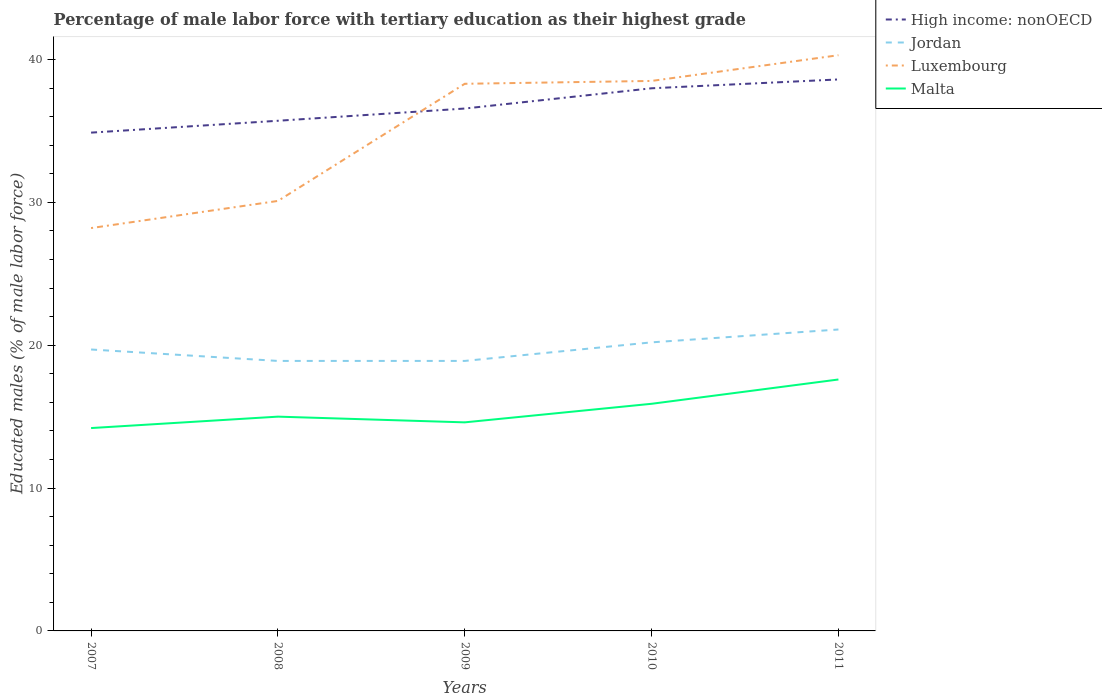How many different coloured lines are there?
Offer a very short reply. 4. Is the number of lines equal to the number of legend labels?
Provide a succinct answer. Yes. Across all years, what is the maximum percentage of male labor force with tertiary education in High income: nonOECD?
Keep it short and to the point. 34.88. In which year was the percentage of male labor force with tertiary education in Jordan maximum?
Provide a succinct answer. 2008. What is the total percentage of male labor force with tertiary education in Luxembourg in the graph?
Your answer should be compact. -1.9. What is the difference between the highest and the second highest percentage of male labor force with tertiary education in Luxembourg?
Provide a short and direct response. 12.1. Is the percentage of male labor force with tertiary education in Luxembourg strictly greater than the percentage of male labor force with tertiary education in Jordan over the years?
Your response must be concise. No. How many lines are there?
Your answer should be very brief. 4. What is the difference between two consecutive major ticks on the Y-axis?
Make the answer very short. 10. Does the graph contain any zero values?
Ensure brevity in your answer.  No. Does the graph contain grids?
Your answer should be very brief. No. Where does the legend appear in the graph?
Offer a terse response. Top right. What is the title of the graph?
Offer a very short reply. Percentage of male labor force with tertiary education as their highest grade. What is the label or title of the Y-axis?
Provide a short and direct response. Educated males (% of male labor force). What is the Educated males (% of male labor force) in High income: nonOECD in 2007?
Offer a terse response. 34.88. What is the Educated males (% of male labor force) in Jordan in 2007?
Your answer should be very brief. 19.7. What is the Educated males (% of male labor force) in Luxembourg in 2007?
Offer a very short reply. 28.2. What is the Educated males (% of male labor force) of Malta in 2007?
Ensure brevity in your answer.  14.2. What is the Educated males (% of male labor force) in High income: nonOECD in 2008?
Give a very brief answer. 35.71. What is the Educated males (% of male labor force) in Jordan in 2008?
Provide a succinct answer. 18.9. What is the Educated males (% of male labor force) of Luxembourg in 2008?
Provide a short and direct response. 30.1. What is the Educated males (% of male labor force) of Malta in 2008?
Keep it short and to the point. 15. What is the Educated males (% of male labor force) of High income: nonOECD in 2009?
Make the answer very short. 36.57. What is the Educated males (% of male labor force) in Jordan in 2009?
Keep it short and to the point. 18.9. What is the Educated males (% of male labor force) in Luxembourg in 2009?
Provide a short and direct response. 38.3. What is the Educated males (% of male labor force) in Malta in 2009?
Your answer should be compact. 14.6. What is the Educated males (% of male labor force) of High income: nonOECD in 2010?
Provide a short and direct response. 37.99. What is the Educated males (% of male labor force) in Jordan in 2010?
Make the answer very short. 20.2. What is the Educated males (% of male labor force) of Luxembourg in 2010?
Provide a short and direct response. 38.5. What is the Educated males (% of male labor force) in Malta in 2010?
Ensure brevity in your answer.  15.9. What is the Educated males (% of male labor force) in High income: nonOECD in 2011?
Offer a very short reply. 38.6. What is the Educated males (% of male labor force) in Jordan in 2011?
Ensure brevity in your answer.  21.1. What is the Educated males (% of male labor force) in Luxembourg in 2011?
Your answer should be compact. 40.3. What is the Educated males (% of male labor force) in Malta in 2011?
Offer a terse response. 17.6. Across all years, what is the maximum Educated males (% of male labor force) in High income: nonOECD?
Ensure brevity in your answer.  38.6. Across all years, what is the maximum Educated males (% of male labor force) of Jordan?
Offer a very short reply. 21.1. Across all years, what is the maximum Educated males (% of male labor force) in Luxembourg?
Offer a terse response. 40.3. Across all years, what is the maximum Educated males (% of male labor force) in Malta?
Your answer should be very brief. 17.6. Across all years, what is the minimum Educated males (% of male labor force) of High income: nonOECD?
Ensure brevity in your answer.  34.88. Across all years, what is the minimum Educated males (% of male labor force) of Jordan?
Give a very brief answer. 18.9. Across all years, what is the minimum Educated males (% of male labor force) of Luxembourg?
Your answer should be very brief. 28.2. Across all years, what is the minimum Educated males (% of male labor force) in Malta?
Offer a very short reply. 14.2. What is the total Educated males (% of male labor force) in High income: nonOECD in the graph?
Ensure brevity in your answer.  183.75. What is the total Educated males (% of male labor force) of Jordan in the graph?
Your response must be concise. 98.8. What is the total Educated males (% of male labor force) in Luxembourg in the graph?
Ensure brevity in your answer.  175.4. What is the total Educated males (% of male labor force) of Malta in the graph?
Offer a very short reply. 77.3. What is the difference between the Educated males (% of male labor force) in High income: nonOECD in 2007 and that in 2008?
Make the answer very short. -0.83. What is the difference between the Educated males (% of male labor force) of Malta in 2007 and that in 2008?
Offer a very short reply. -0.8. What is the difference between the Educated males (% of male labor force) in High income: nonOECD in 2007 and that in 2009?
Keep it short and to the point. -1.69. What is the difference between the Educated males (% of male labor force) in Luxembourg in 2007 and that in 2009?
Ensure brevity in your answer.  -10.1. What is the difference between the Educated males (% of male labor force) in Malta in 2007 and that in 2009?
Keep it short and to the point. -0.4. What is the difference between the Educated males (% of male labor force) of High income: nonOECD in 2007 and that in 2010?
Ensure brevity in your answer.  -3.1. What is the difference between the Educated males (% of male labor force) of Jordan in 2007 and that in 2010?
Keep it short and to the point. -0.5. What is the difference between the Educated males (% of male labor force) of Luxembourg in 2007 and that in 2010?
Your response must be concise. -10.3. What is the difference between the Educated males (% of male labor force) of Malta in 2007 and that in 2010?
Provide a succinct answer. -1.7. What is the difference between the Educated males (% of male labor force) in High income: nonOECD in 2007 and that in 2011?
Provide a succinct answer. -3.72. What is the difference between the Educated males (% of male labor force) in High income: nonOECD in 2008 and that in 2009?
Your answer should be compact. -0.86. What is the difference between the Educated males (% of male labor force) in Jordan in 2008 and that in 2009?
Give a very brief answer. 0. What is the difference between the Educated males (% of male labor force) of Luxembourg in 2008 and that in 2009?
Give a very brief answer. -8.2. What is the difference between the Educated males (% of male labor force) of High income: nonOECD in 2008 and that in 2010?
Give a very brief answer. -2.27. What is the difference between the Educated males (% of male labor force) of Luxembourg in 2008 and that in 2010?
Offer a very short reply. -8.4. What is the difference between the Educated males (% of male labor force) of High income: nonOECD in 2008 and that in 2011?
Make the answer very short. -2.89. What is the difference between the Educated males (% of male labor force) of Luxembourg in 2008 and that in 2011?
Your answer should be compact. -10.2. What is the difference between the Educated males (% of male labor force) in High income: nonOECD in 2009 and that in 2010?
Offer a terse response. -1.42. What is the difference between the Educated males (% of male labor force) of Luxembourg in 2009 and that in 2010?
Ensure brevity in your answer.  -0.2. What is the difference between the Educated males (% of male labor force) of Malta in 2009 and that in 2010?
Offer a very short reply. -1.3. What is the difference between the Educated males (% of male labor force) of High income: nonOECD in 2009 and that in 2011?
Offer a very short reply. -2.04. What is the difference between the Educated males (% of male labor force) of Luxembourg in 2009 and that in 2011?
Provide a succinct answer. -2. What is the difference between the Educated males (% of male labor force) of Malta in 2009 and that in 2011?
Keep it short and to the point. -3. What is the difference between the Educated males (% of male labor force) of High income: nonOECD in 2010 and that in 2011?
Make the answer very short. -0.62. What is the difference between the Educated males (% of male labor force) in Jordan in 2010 and that in 2011?
Your answer should be compact. -0.9. What is the difference between the Educated males (% of male labor force) of Luxembourg in 2010 and that in 2011?
Ensure brevity in your answer.  -1.8. What is the difference between the Educated males (% of male labor force) of High income: nonOECD in 2007 and the Educated males (% of male labor force) of Jordan in 2008?
Offer a very short reply. 15.98. What is the difference between the Educated males (% of male labor force) of High income: nonOECD in 2007 and the Educated males (% of male labor force) of Luxembourg in 2008?
Provide a succinct answer. 4.78. What is the difference between the Educated males (% of male labor force) of High income: nonOECD in 2007 and the Educated males (% of male labor force) of Malta in 2008?
Provide a short and direct response. 19.88. What is the difference between the Educated males (% of male labor force) in Jordan in 2007 and the Educated males (% of male labor force) in Luxembourg in 2008?
Provide a succinct answer. -10.4. What is the difference between the Educated males (% of male labor force) of High income: nonOECD in 2007 and the Educated males (% of male labor force) of Jordan in 2009?
Your answer should be very brief. 15.98. What is the difference between the Educated males (% of male labor force) in High income: nonOECD in 2007 and the Educated males (% of male labor force) in Luxembourg in 2009?
Give a very brief answer. -3.42. What is the difference between the Educated males (% of male labor force) of High income: nonOECD in 2007 and the Educated males (% of male labor force) of Malta in 2009?
Ensure brevity in your answer.  20.28. What is the difference between the Educated males (% of male labor force) of Jordan in 2007 and the Educated males (% of male labor force) of Luxembourg in 2009?
Offer a very short reply. -18.6. What is the difference between the Educated males (% of male labor force) in Luxembourg in 2007 and the Educated males (% of male labor force) in Malta in 2009?
Your response must be concise. 13.6. What is the difference between the Educated males (% of male labor force) in High income: nonOECD in 2007 and the Educated males (% of male labor force) in Jordan in 2010?
Offer a very short reply. 14.68. What is the difference between the Educated males (% of male labor force) in High income: nonOECD in 2007 and the Educated males (% of male labor force) in Luxembourg in 2010?
Give a very brief answer. -3.62. What is the difference between the Educated males (% of male labor force) of High income: nonOECD in 2007 and the Educated males (% of male labor force) of Malta in 2010?
Offer a very short reply. 18.98. What is the difference between the Educated males (% of male labor force) of Jordan in 2007 and the Educated males (% of male labor force) of Luxembourg in 2010?
Keep it short and to the point. -18.8. What is the difference between the Educated males (% of male labor force) in Jordan in 2007 and the Educated males (% of male labor force) in Malta in 2010?
Make the answer very short. 3.8. What is the difference between the Educated males (% of male labor force) in Luxembourg in 2007 and the Educated males (% of male labor force) in Malta in 2010?
Keep it short and to the point. 12.3. What is the difference between the Educated males (% of male labor force) in High income: nonOECD in 2007 and the Educated males (% of male labor force) in Jordan in 2011?
Your response must be concise. 13.78. What is the difference between the Educated males (% of male labor force) of High income: nonOECD in 2007 and the Educated males (% of male labor force) of Luxembourg in 2011?
Offer a very short reply. -5.42. What is the difference between the Educated males (% of male labor force) in High income: nonOECD in 2007 and the Educated males (% of male labor force) in Malta in 2011?
Your answer should be very brief. 17.28. What is the difference between the Educated males (% of male labor force) of Jordan in 2007 and the Educated males (% of male labor force) of Luxembourg in 2011?
Your answer should be compact. -20.6. What is the difference between the Educated males (% of male labor force) in Jordan in 2007 and the Educated males (% of male labor force) in Malta in 2011?
Keep it short and to the point. 2.1. What is the difference between the Educated males (% of male labor force) in High income: nonOECD in 2008 and the Educated males (% of male labor force) in Jordan in 2009?
Ensure brevity in your answer.  16.81. What is the difference between the Educated males (% of male labor force) of High income: nonOECD in 2008 and the Educated males (% of male labor force) of Luxembourg in 2009?
Offer a very short reply. -2.59. What is the difference between the Educated males (% of male labor force) in High income: nonOECD in 2008 and the Educated males (% of male labor force) in Malta in 2009?
Make the answer very short. 21.11. What is the difference between the Educated males (% of male labor force) of Jordan in 2008 and the Educated males (% of male labor force) of Luxembourg in 2009?
Your answer should be very brief. -19.4. What is the difference between the Educated males (% of male labor force) of Luxembourg in 2008 and the Educated males (% of male labor force) of Malta in 2009?
Keep it short and to the point. 15.5. What is the difference between the Educated males (% of male labor force) in High income: nonOECD in 2008 and the Educated males (% of male labor force) in Jordan in 2010?
Your response must be concise. 15.51. What is the difference between the Educated males (% of male labor force) of High income: nonOECD in 2008 and the Educated males (% of male labor force) of Luxembourg in 2010?
Your answer should be very brief. -2.79. What is the difference between the Educated males (% of male labor force) in High income: nonOECD in 2008 and the Educated males (% of male labor force) in Malta in 2010?
Provide a succinct answer. 19.81. What is the difference between the Educated males (% of male labor force) of Jordan in 2008 and the Educated males (% of male labor force) of Luxembourg in 2010?
Your answer should be compact. -19.6. What is the difference between the Educated males (% of male labor force) of Jordan in 2008 and the Educated males (% of male labor force) of Malta in 2010?
Ensure brevity in your answer.  3. What is the difference between the Educated males (% of male labor force) of High income: nonOECD in 2008 and the Educated males (% of male labor force) of Jordan in 2011?
Make the answer very short. 14.61. What is the difference between the Educated males (% of male labor force) in High income: nonOECD in 2008 and the Educated males (% of male labor force) in Luxembourg in 2011?
Ensure brevity in your answer.  -4.59. What is the difference between the Educated males (% of male labor force) in High income: nonOECD in 2008 and the Educated males (% of male labor force) in Malta in 2011?
Keep it short and to the point. 18.11. What is the difference between the Educated males (% of male labor force) in Jordan in 2008 and the Educated males (% of male labor force) in Luxembourg in 2011?
Provide a short and direct response. -21.4. What is the difference between the Educated males (% of male labor force) of Jordan in 2008 and the Educated males (% of male labor force) of Malta in 2011?
Keep it short and to the point. 1.3. What is the difference between the Educated males (% of male labor force) of Luxembourg in 2008 and the Educated males (% of male labor force) of Malta in 2011?
Provide a short and direct response. 12.5. What is the difference between the Educated males (% of male labor force) in High income: nonOECD in 2009 and the Educated males (% of male labor force) in Jordan in 2010?
Provide a succinct answer. 16.37. What is the difference between the Educated males (% of male labor force) of High income: nonOECD in 2009 and the Educated males (% of male labor force) of Luxembourg in 2010?
Give a very brief answer. -1.93. What is the difference between the Educated males (% of male labor force) in High income: nonOECD in 2009 and the Educated males (% of male labor force) in Malta in 2010?
Provide a short and direct response. 20.67. What is the difference between the Educated males (% of male labor force) in Jordan in 2009 and the Educated males (% of male labor force) in Luxembourg in 2010?
Your answer should be very brief. -19.6. What is the difference between the Educated males (% of male labor force) of Jordan in 2009 and the Educated males (% of male labor force) of Malta in 2010?
Your answer should be very brief. 3. What is the difference between the Educated males (% of male labor force) of Luxembourg in 2009 and the Educated males (% of male labor force) of Malta in 2010?
Offer a very short reply. 22.4. What is the difference between the Educated males (% of male labor force) of High income: nonOECD in 2009 and the Educated males (% of male labor force) of Jordan in 2011?
Your answer should be compact. 15.47. What is the difference between the Educated males (% of male labor force) in High income: nonOECD in 2009 and the Educated males (% of male labor force) in Luxembourg in 2011?
Give a very brief answer. -3.73. What is the difference between the Educated males (% of male labor force) in High income: nonOECD in 2009 and the Educated males (% of male labor force) in Malta in 2011?
Your response must be concise. 18.97. What is the difference between the Educated males (% of male labor force) of Jordan in 2009 and the Educated males (% of male labor force) of Luxembourg in 2011?
Your answer should be very brief. -21.4. What is the difference between the Educated males (% of male labor force) in Luxembourg in 2009 and the Educated males (% of male labor force) in Malta in 2011?
Keep it short and to the point. 20.7. What is the difference between the Educated males (% of male labor force) of High income: nonOECD in 2010 and the Educated males (% of male labor force) of Jordan in 2011?
Give a very brief answer. 16.89. What is the difference between the Educated males (% of male labor force) in High income: nonOECD in 2010 and the Educated males (% of male labor force) in Luxembourg in 2011?
Make the answer very short. -2.31. What is the difference between the Educated males (% of male labor force) in High income: nonOECD in 2010 and the Educated males (% of male labor force) in Malta in 2011?
Offer a very short reply. 20.39. What is the difference between the Educated males (% of male labor force) of Jordan in 2010 and the Educated males (% of male labor force) of Luxembourg in 2011?
Offer a very short reply. -20.1. What is the difference between the Educated males (% of male labor force) in Jordan in 2010 and the Educated males (% of male labor force) in Malta in 2011?
Offer a very short reply. 2.6. What is the difference between the Educated males (% of male labor force) in Luxembourg in 2010 and the Educated males (% of male labor force) in Malta in 2011?
Provide a succinct answer. 20.9. What is the average Educated males (% of male labor force) of High income: nonOECD per year?
Make the answer very short. 36.75. What is the average Educated males (% of male labor force) of Jordan per year?
Keep it short and to the point. 19.76. What is the average Educated males (% of male labor force) in Luxembourg per year?
Provide a succinct answer. 35.08. What is the average Educated males (% of male labor force) of Malta per year?
Keep it short and to the point. 15.46. In the year 2007, what is the difference between the Educated males (% of male labor force) in High income: nonOECD and Educated males (% of male labor force) in Jordan?
Ensure brevity in your answer.  15.18. In the year 2007, what is the difference between the Educated males (% of male labor force) of High income: nonOECD and Educated males (% of male labor force) of Luxembourg?
Your answer should be very brief. 6.68. In the year 2007, what is the difference between the Educated males (% of male labor force) in High income: nonOECD and Educated males (% of male labor force) in Malta?
Your answer should be very brief. 20.68. In the year 2007, what is the difference between the Educated males (% of male labor force) of Jordan and Educated males (% of male labor force) of Luxembourg?
Offer a very short reply. -8.5. In the year 2007, what is the difference between the Educated males (% of male labor force) of Luxembourg and Educated males (% of male labor force) of Malta?
Your answer should be very brief. 14. In the year 2008, what is the difference between the Educated males (% of male labor force) of High income: nonOECD and Educated males (% of male labor force) of Jordan?
Ensure brevity in your answer.  16.81. In the year 2008, what is the difference between the Educated males (% of male labor force) in High income: nonOECD and Educated males (% of male labor force) in Luxembourg?
Ensure brevity in your answer.  5.61. In the year 2008, what is the difference between the Educated males (% of male labor force) of High income: nonOECD and Educated males (% of male labor force) of Malta?
Provide a short and direct response. 20.71. In the year 2008, what is the difference between the Educated males (% of male labor force) in Luxembourg and Educated males (% of male labor force) in Malta?
Offer a terse response. 15.1. In the year 2009, what is the difference between the Educated males (% of male labor force) in High income: nonOECD and Educated males (% of male labor force) in Jordan?
Offer a very short reply. 17.67. In the year 2009, what is the difference between the Educated males (% of male labor force) of High income: nonOECD and Educated males (% of male labor force) of Luxembourg?
Offer a very short reply. -1.73. In the year 2009, what is the difference between the Educated males (% of male labor force) in High income: nonOECD and Educated males (% of male labor force) in Malta?
Ensure brevity in your answer.  21.97. In the year 2009, what is the difference between the Educated males (% of male labor force) of Jordan and Educated males (% of male labor force) of Luxembourg?
Your answer should be very brief. -19.4. In the year 2009, what is the difference between the Educated males (% of male labor force) in Jordan and Educated males (% of male labor force) in Malta?
Provide a short and direct response. 4.3. In the year 2009, what is the difference between the Educated males (% of male labor force) of Luxembourg and Educated males (% of male labor force) of Malta?
Your response must be concise. 23.7. In the year 2010, what is the difference between the Educated males (% of male labor force) of High income: nonOECD and Educated males (% of male labor force) of Jordan?
Keep it short and to the point. 17.79. In the year 2010, what is the difference between the Educated males (% of male labor force) of High income: nonOECD and Educated males (% of male labor force) of Luxembourg?
Ensure brevity in your answer.  -0.51. In the year 2010, what is the difference between the Educated males (% of male labor force) in High income: nonOECD and Educated males (% of male labor force) in Malta?
Give a very brief answer. 22.09. In the year 2010, what is the difference between the Educated males (% of male labor force) in Jordan and Educated males (% of male labor force) in Luxembourg?
Provide a succinct answer. -18.3. In the year 2010, what is the difference between the Educated males (% of male labor force) of Luxembourg and Educated males (% of male labor force) of Malta?
Your answer should be compact. 22.6. In the year 2011, what is the difference between the Educated males (% of male labor force) in High income: nonOECD and Educated males (% of male labor force) in Jordan?
Your answer should be very brief. 17.5. In the year 2011, what is the difference between the Educated males (% of male labor force) in High income: nonOECD and Educated males (% of male labor force) in Luxembourg?
Provide a short and direct response. -1.7. In the year 2011, what is the difference between the Educated males (% of male labor force) in High income: nonOECD and Educated males (% of male labor force) in Malta?
Your response must be concise. 21. In the year 2011, what is the difference between the Educated males (% of male labor force) of Jordan and Educated males (% of male labor force) of Luxembourg?
Your answer should be very brief. -19.2. In the year 2011, what is the difference between the Educated males (% of male labor force) of Jordan and Educated males (% of male labor force) of Malta?
Offer a terse response. 3.5. In the year 2011, what is the difference between the Educated males (% of male labor force) in Luxembourg and Educated males (% of male labor force) in Malta?
Keep it short and to the point. 22.7. What is the ratio of the Educated males (% of male labor force) of High income: nonOECD in 2007 to that in 2008?
Make the answer very short. 0.98. What is the ratio of the Educated males (% of male labor force) in Jordan in 2007 to that in 2008?
Your answer should be compact. 1.04. What is the ratio of the Educated males (% of male labor force) in Luxembourg in 2007 to that in 2008?
Provide a succinct answer. 0.94. What is the ratio of the Educated males (% of male labor force) of Malta in 2007 to that in 2008?
Keep it short and to the point. 0.95. What is the ratio of the Educated males (% of male labor force) of High income: nonOECD in 2007 to that in 2009?
Your answer should be very brief. 0.95. What is the ratio of the Educated males (% of male labor force) of Jordan in 2007 to that in 2009?
Ensure brevity in your answer.  1.04. What is the ratio of the Educated males (% of male labor force) of Luxembourg in 2007 to that in 2009?
Your answer should be compact. 0.74. What is the ratio of the Educated males (% of male labor force) of Malta in 2007 to that in 2009?
Keep it short and to the point. 0.97. What is the ratio of the Educated males (% of male labor force) in High income: nonOECD in 2007 to that in 2010?
Your answer should be very brief. 0.92. What is the ratio of the Educated males (% of male labor force) of Jordan in 2007 to that in 2010?
Provide a succinct answer. 0.98. What is the ratio of the Educated males (% of male labor force) in Luxembourg in 2007 to that in 2010?
Provide a succinct answer. 0.73. What is the ratio of the Educated males (% of male labor force) in Malta in 2007 to that in 2010?
Give a very brief answer. 0.89. What is the ratio of the Educated males (% of male labor force) of High income: nonOECD in 2007 to that in 2011?
Ensure brevity in your answer.  0.9. What is the ratio of the Educated males (% of male labor force) in Jordan in 2007 to that in 2011?
Your response must be concise. 0.93. What is the ratio of the Educated males (% of male labor force) in Luxembourg in 2007 to that in 2011?
Make the answer very short. 0.7. What is the ratio of the Educated males (% of male labor force) of Malta in 2007 to that in 2011?
Offer a terse response. 0.81. What is the ratio of the Educated males (% of male labor force) of High income: nonOECD in 2008 to that in 2009?
Provide a succinct answer. 0.98. What is the ratio of the Educated males (% of male labor force) in Jordan in 2008 to that in 2009?
Offer a very short reply. 1. What is the ratio of the Educated males (% of male labor force) of Luxembourg in 2008 to that in 2009?
Provide a short and direct response. 0.79. What is the ratio of the Educated males (% of male labor force) in Malta in 2008 to that in 2009?
Your answer should be compact. 1.03. What is the ratio of the Educated males (% of male labor force) of High income: nonOECD in 2008 to that in 2010?
Your answer should be compact. 0.94. What is the ratio of the Educated males (% of male labor force) of Jordan in 2008 to that in 2010?
Provide a succinct answer. 0.94. What is the ratio of the Educated males (% of male labor force) of Luxembourg in 2008 to that in 2010?
Give a very brief answer. 0.78. What is the ratio of the Educated males (% of male labor force) of Malta in 2008 to that in 2010?
Make the answer very short. 0.94. What is the ratio of the Educated males (% of male labor force) in High income: nonOECD in 2008 to that in 2011?
Provide a succinct answer. 0.93. What is the ratio of the Educated males (% of male labor force) in Jordan in 2008 to that in 2011?
Provide a succinct answer. 0.9. What is the ratio of the Educated males (% of male labor force) of Luxembourg in 2008 to that in 2011?
Provide a succinct answer. 0.75. What is the ratio of the Educated males (% of male labor force) in Malta in 2008 to that in 2011?
Your answer should be compact. 0.85. What is the ratio of the Educated males (% of male labor force) in High income: nonOECD in 2009 to that in 2010?
Your answer should be compact. 0.96. What is the ratio of the Educated males (% of male labor force) of Jordan in 2009 to that in 2010?
Provide a short and direct response. 0.94. What is the ratio of the Educated males (% of male labor force) in Luxembourg in 2009 to that in 2010?
Your answer should be very brief. 0.99. What is the ratio of the Educated males (% of male labor force) of Malta in 2009 to that in 2010?
Offer a terse response. 0.92. What is the ratio of the Educated males (% of male labor force) in High income: nonOECD in 2009 to that in 2011?
Offer a terse response. 0.95. What is the ratio of the Educated males (% of male labor force) in Jordan in 2009 to that in 2011?
Your answer should be compact. 0.9. What is the ratio of the Educated males (% of male labor force) in Luxembourg in 2009 to that in 2011?
Your answer should be compact. 0.95. What is the ratio of the Educated males (% of male labor force) in Malta in 2009 to that in 2011?
Your response must be concise. 0.83. What is the ratio of the Educated males (% of male labor force) in Jordan in 2010 to that in 2011?
Offer a terse response. 0.96. What is the ratio of the Educated males (% of male labor force) of Luxembourg in 2010 to that in 2011?
Provide a short and direct response. 0.96. What is the ratio of the Educated males (% of male labor force) of Malta in 2010 to that in 2011?
Ensure brevity in your answer.  0.9. What is the difference between the highest and the second highest Educated males (% of male labor force) of High income: nonOECD?
Give a very brief answer. 0.62. What is the difference between the highest and the lowest Educated males (% of male labor force) of High income: nonOECD?
Offer a very short reply. 3.72. What is the difference between the highest and the lowest Educated males (% of male labor force) of Jordan?
Your answer should be very brief. 2.2. 